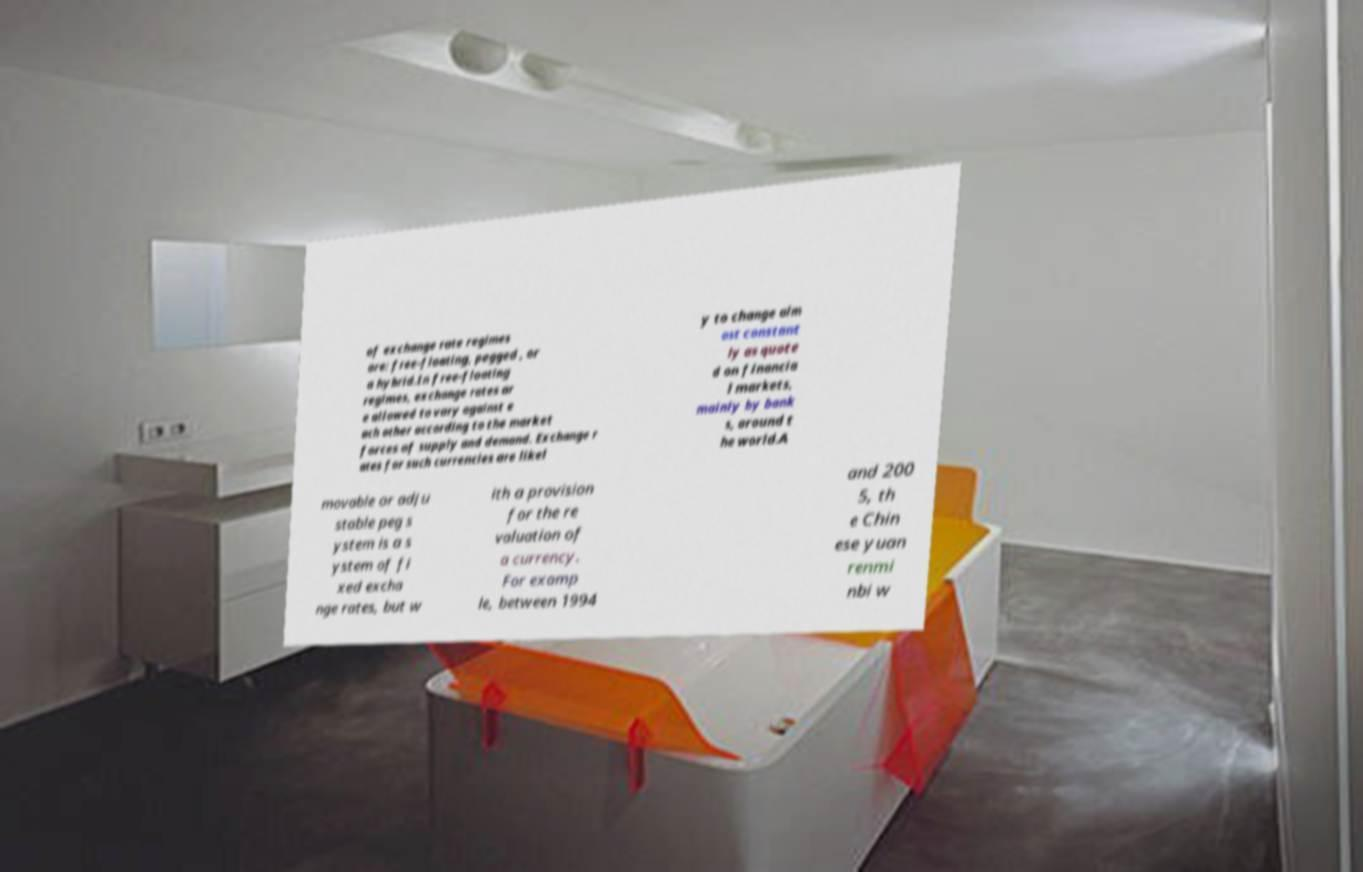Could you extract and type out the text from this image? of exchange rate regimes are: free-floating, pegged , or a hybrid.In free-floating regimes, exchange rates ar e allowed to vary against e ach other according to the market forces of supply and demand. Exchange r ates for such currencies are likel y to change alm ost constant ly as quote d on financia l markets, mainly by bank s, around t he world.A movable or adju stable peg s ystem is a s ystem of fi xed excha nge rates, but w ith a provision for the re valuation of a currency. For examp le, between 1994 and 200 5, th e Chin ese yuan renmi nbi w 